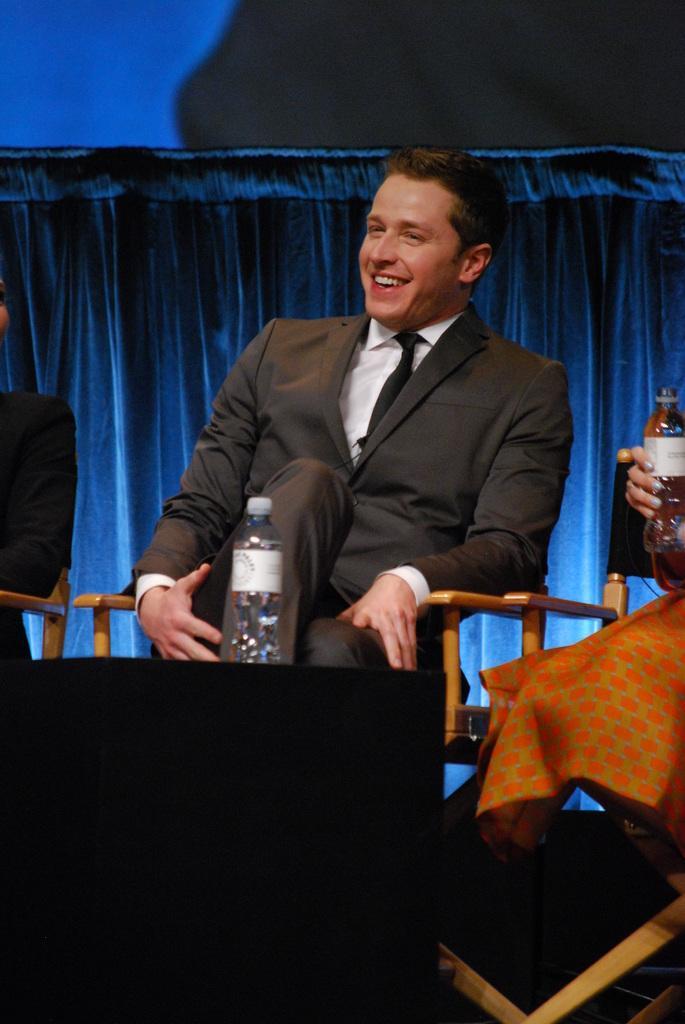Describe this image in one or two sentences. In this image I can see a man is sitting on a chair. I can also see a smile on his face. Here I can see a water bottle. I can see he is wearing suit and tie. 